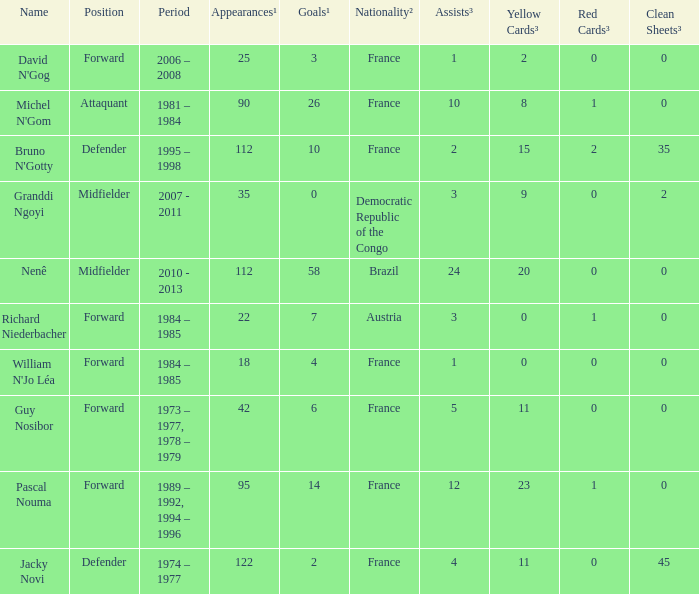List the number of active years for attaquant. 1981 – 1984. 